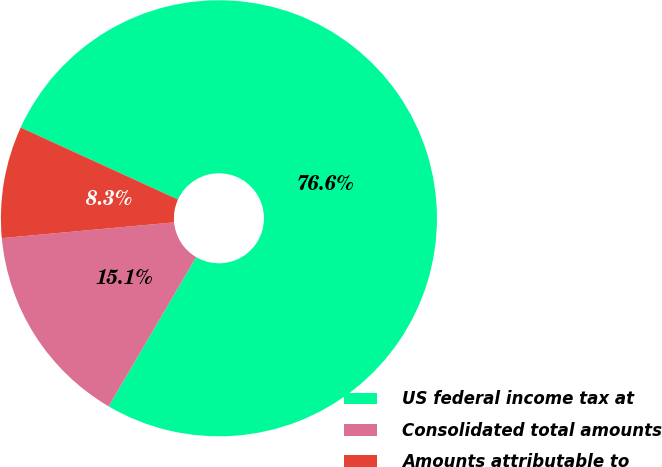<chart> <loc_0><loc_0><loc_500><loc_500><pie_chart><fcel>US federal income tax at<fcel>Consolidated total amounts<fcel>Amounts attributable to<nl><fcel>76.61%<fcel>15.11%<fcel>8.28%<nl></chart> 